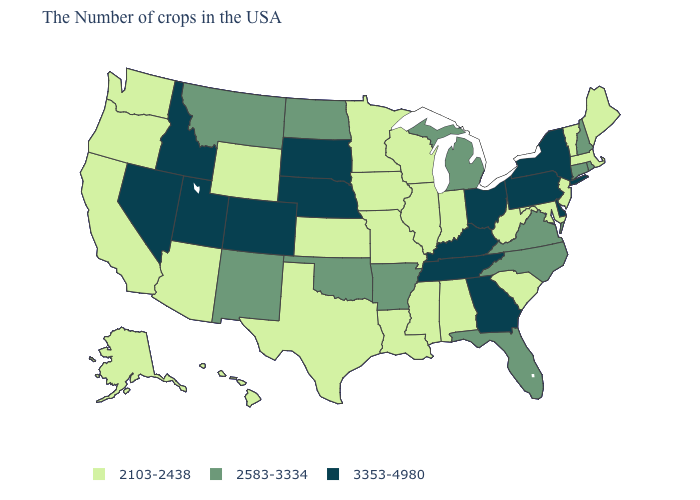Among the states that border South Dakota , which have the lowest value?
Short answer required. Minnesota, Iowa, Wyoming. What is the value of Tennessee?
Short answer required. 3353-4980. Does the first symbol in the legend represent the smallest category?
Quick response, please. Yes. How many symbols are there in the legend?
Quick response, please. 3. What is the value of Arkansas?
Short answer required. 2583-3334. What is the value of New Jersey?
Give a very brief answer. 2103-2438. What is the highest value in the USA?
Answer briefly. 3353-4980. What is the highest value in the USA?
Quick response, please. 3353-4980. What is the lowest value in the West?
Answer briefly. 2103-2438. Does Pennsylvania have the highest value in the Northeast?
Answer briefly. Yes. Does the map have missing data?
Write a very short answer. No. Name the states that have a value in the range 2583-3334?
Concise answer only. Rhode Island, New Hampshire, Connecticut, Virginia, North Carolina, Florida, Michigan, Arkansas, Oklahoma, North Dakota, New Mexico, Montana. Does the first symbol in the legend represent the smallest category?
Write a very short answer. Yes. Name the states that have a value in the range 2103-2438?
Keep it brief. Maine, Massachusetts, Vermont, New Jersey, Maryland, South Carolina, West Virginia, Indiana, Alabama, Wisconsin, Illinois, Mississippi, Louisiana, Missouri, Minnesota, Iowa, Kansas, Texas, Wyoming, Arizona, California, Washington, Oregon, Alaska, Hawaii. Which states have the highest value in the USA?
Answer briefly. New York, Delaware, Pennsylvania, Ohio, Georgia, Kentucky, Tennessee, Nebraska, South Dakota, Colorado, Utah, Idaho, Nevada. 